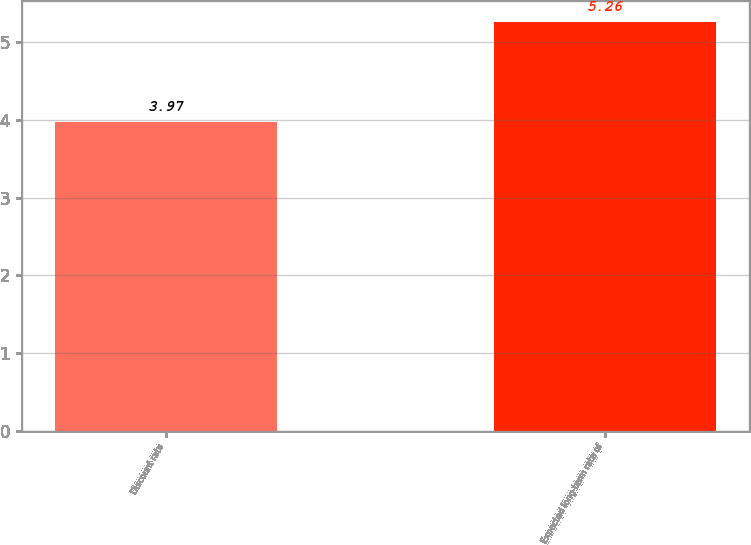Convert chart. <chart><loc_0><loc_0><loc_500><loc_500><bar_chart><fcel>Discount rate<fcel>Expected long-term rate of<nl><fcel>3.97<fcel>5.26<nl></chart> 